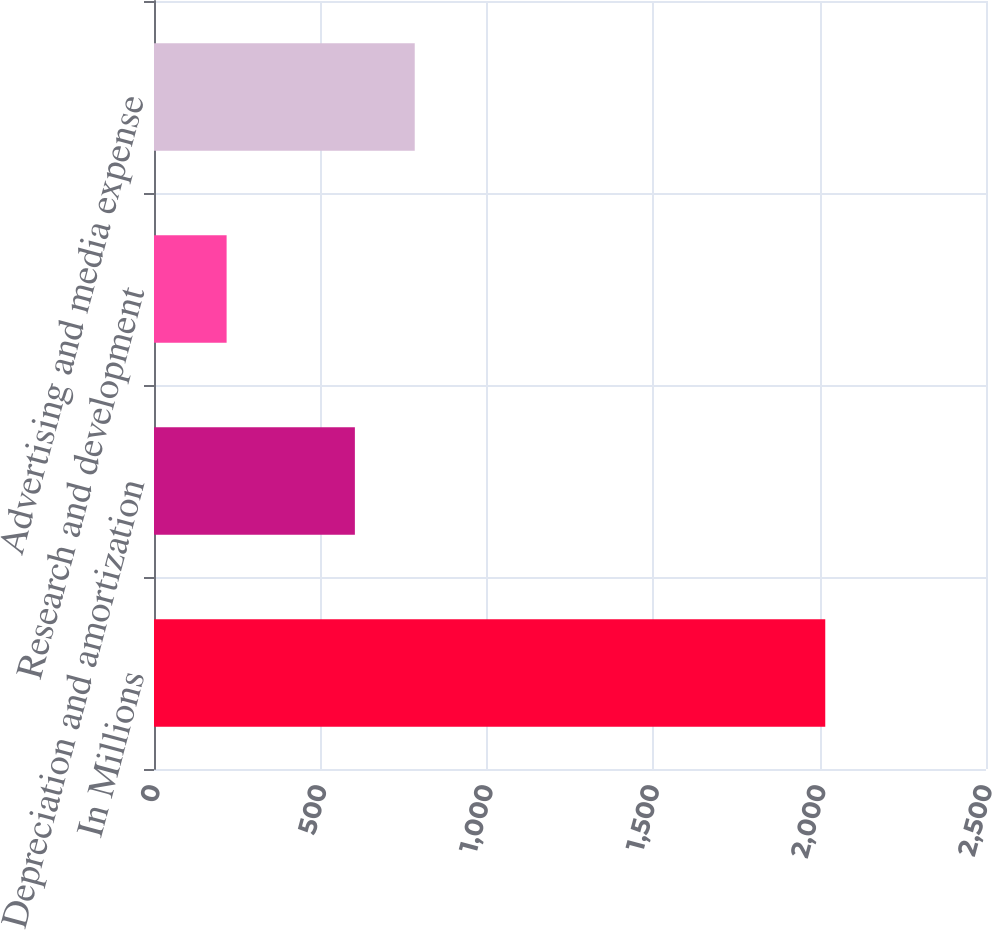Convert chart to OTSL. <chart><loc_0><loc_0><loc_500><loc_500><bar_chart><fcel>In Millions<fcel>Depreciation and amortization<fcel>Research and development<fcel>Advertising and media expense<nl><fcel>2017<fcel>603.6<fcel>218.2<fcel>783.48<nl></chart> 